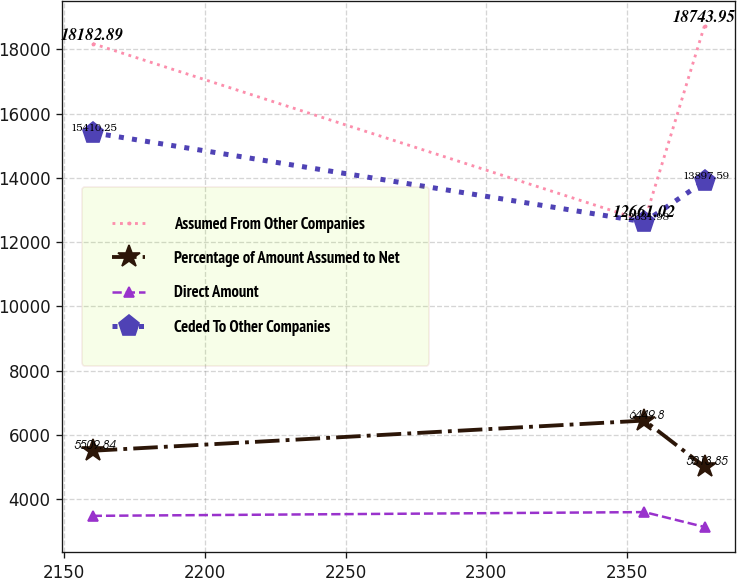<chart> <loc_0><loc_0><loc_500><loc_500><line_chart><ecel><fcel>Assumed From Other Companies<fcel>Percentage of Amount Assumed to Net<fcel>Direct Amount<fcel>Ceded To Other Companies<nl><fcel>2160.22<fcel>18182.9<fcel>5509.84<fcel>3483.7<fcel>15410.2<nl><fcel>2356.17<fcel>12661<fcel>6449.8<fcel>3600.43<fcel>12632<nl><fcel>2377.49<fcel>18744<fcel>5013.85<fcel>3136.65<fcel>13897.6<nl></chart> 